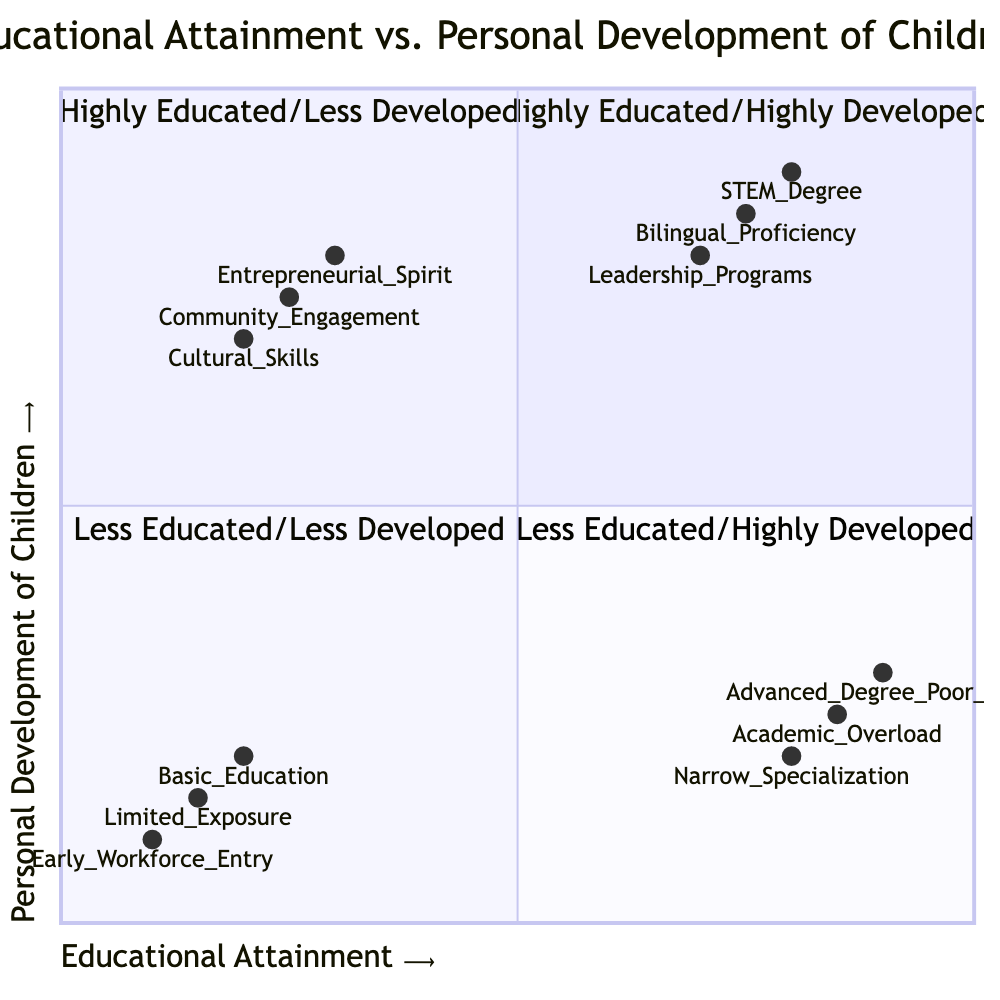What is the highest element in the Highly Educated/Highly Developed quadrant? The element at the highest position in this quadrant is "STEM Degree," which corresponds to the coordinates [0.8, 0.9].
Answer: STEM Degree How many elements are in the Less Educated/Less Developed quadrant? There are three elements listed in the Less Educated/Less Developed quadrant: "Basic Education and Minimal Life Skills," "Limited Exposure," and "Early Workforce Entry."
Answer: 3 Which element has the lowest score in the Personal Development of Children axis? The element with the lowest score in the Personal Development axis is "Early Workforce Entry," which has a y-coordinate of 0.1.
Answer: Early Workforce Entry What is the average Educational Attainment score of the elements in the Highly Educated/Less Developed quadrant? The average score is calculated as follows: (0.9 + 0.85 + 0.8) / 3 = 0.85, so the average is 0.85.
Answer: 0.85 Which quadrant contains elements focused on community engagement? The elements that focus on community engagement are found in the Less Educated/Highly Developed quadrant, specifically "Community Engagement."
Answer: Less Educated/Highly Developed Between "Bilingual Proficiency" and "Leadership Programs," which has a higher Personal Development score? "Bilingual Proficiency" has a Personal Development score of 0.85 while "Leadership Programs" has a score of 0.8. Thus, "Bilingual Proficiency" is higher.
Answer: Bilingual Proficiency How many elements in the Highly Educated/Less Developed quadrant show signs of interpersonal skill challenges? There are three elements in this quadrant that imply challenges with interpersonal skills, specifically, "Advanced Degree but Poor Interpersonal Skills," "Academic Overload," and "Narrow Field Specialization."
Answer: 3 Which quadrant has the least focus on education but high personal development? The Less Educated/Highly Developed quadrant has less focus on education while exhibiting high personal development skills, as seen in elements like "Entrepreneurial Spirit" and "Cultural Skills."
Answer: Less Educated/Highly Developed What is the y-coordinate of the "Narrow Specialization" element? The y-coordinate for the "Narrow Specialization" element is 0.2.
Answer: 0.2 What categorization does "Cultural Skills" fall under in the quadrant? "Cultural Skills" falls under the Less Educated/Highly Developed quadrant as it reflects high personal development despite lower educational attainment.
Answer: Less Educated/Highly Developed 